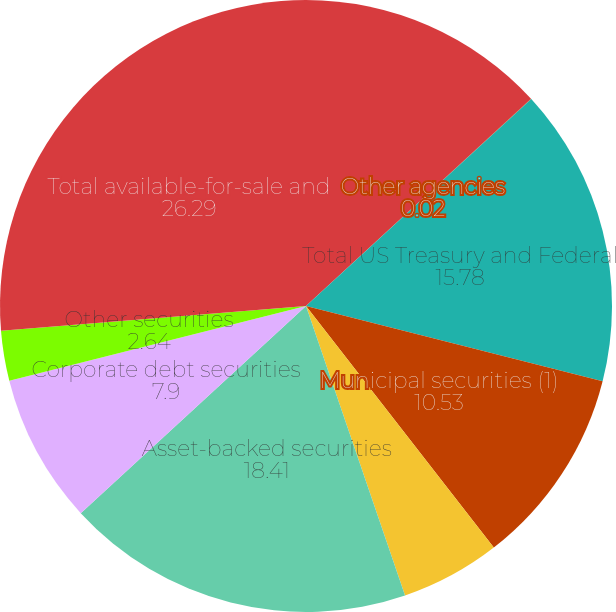Convert chart. <chart><loc_0><loc_0><loc_500><loc_500><pie_chart><fcel>Mortgage-backed securities<fcel>Other agencies<fcel>Total US Treasury and Federal<fcel>Municipal securities (1)<fcel>Private-label CMO<fcel>Asset-backed securities<fcel>Corporate debt securities<fcel>Other securities<fcel>Total available-for-sale and<nl><fcel>13.15%<fcel>0.02%<fcel>15.78%<fcel>10.53%<fcel>5.27%<fcel>18.41%<fcel>7.9%<fcel>2.64%<fcel>26.29%<nl></chart> 